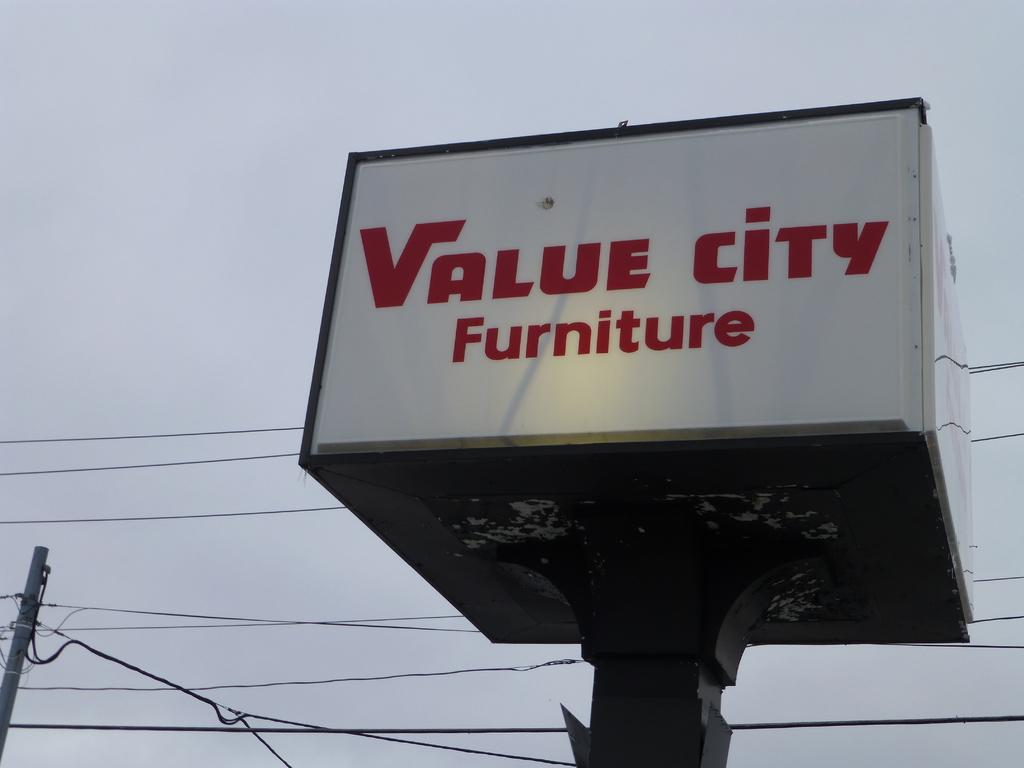<image>
Describe the image concisely. A large cube shaped sign for Value city furniture has a single spotlight aimed at it. 